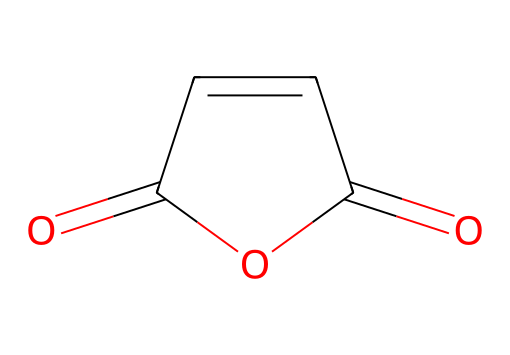What is the molecular formula of this compound? The structure indicates the presence of two carbonyl (C=O) groups and four carbon (C) atoms, leading to a molecular formula of C4H2O3.
Answer: C4H2O3 How many double bonds are present in this structure? The structure shows two double bonds, one between the carbon and oxygen in each of the carbonyls and one between the two carbon atoms.
Answer: 3 What type of chemical is maleic anhydride? Given the anhydride and cyclic structure, this compound is classified as an acid anhydride.
Answer: acid anhydride How many rings are in the molecular structure? The structure contains one cyclic component, which is the ring formed by the carbon and oxygen atoms.
Answer: 1 Which functional groups are present in maleic anhydride? The chemical structure includes two carbonyl groups (C=O) and a cyclic ether linkage, characteristic of anhydrides.
Answer: carbonyl, anhydride How does the structure influence its use in medical polymers? The reactive carbonyl groups allow maleic anhydride to participate in polymerization reactions, enhancing the formation of durable and flexible medical polymers.
Answer: reactive groups 